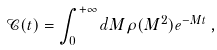<formula> <loc_0><loc_0><loc_500><loc_500>\mathcal { C } ( t ) = \int _ { 0 } ^ { + \infty } d M \rho ( M ^ { 2 } ) e ^ { - M t } \, ,</formula> 